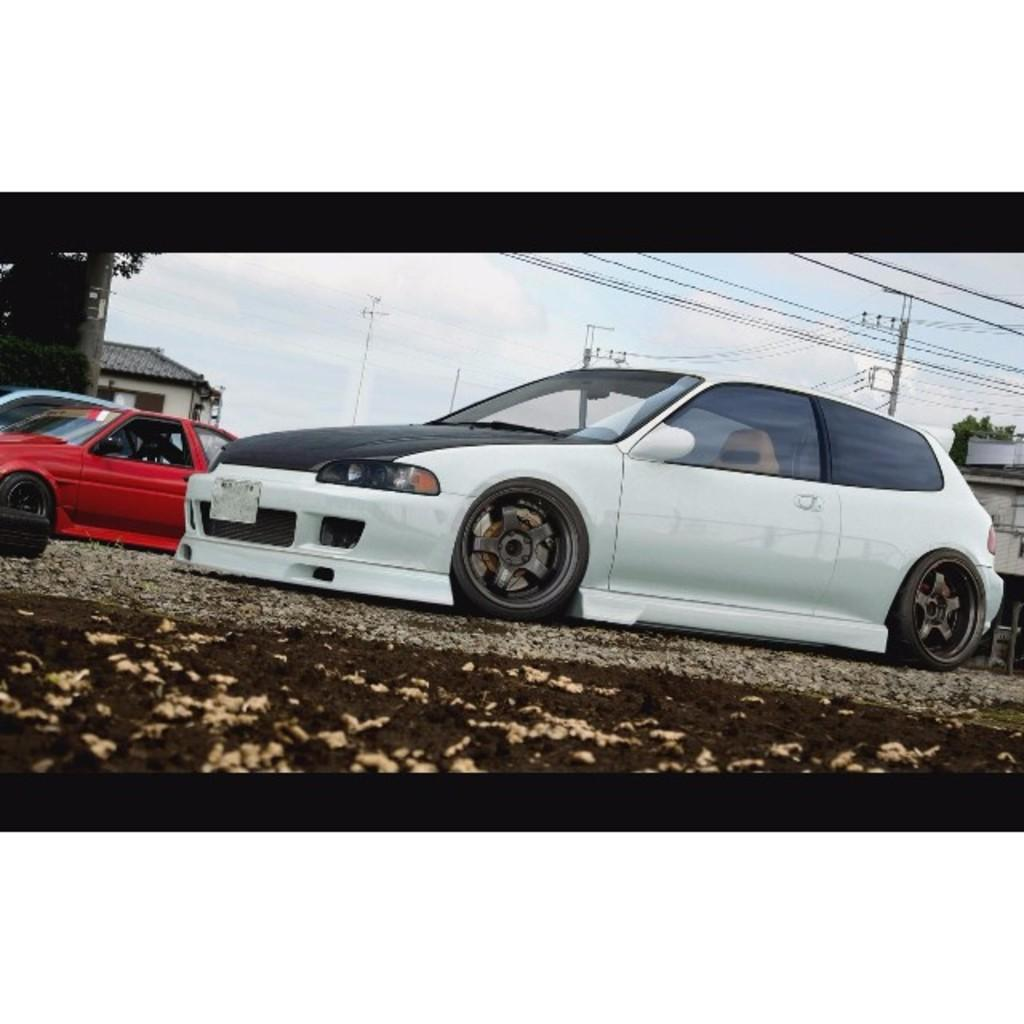What are the main subjects in the center of the image? There are two cars in the center of the image. What can be seen in the background of the image? There are houses and poles with wires in the background of the image. What type of vegetation is at the bottom of the image? There is grass at the bottom of the image. What effect does the temper of the cars have on the grass in the image? There is no indication of the cars' temper in the image, and the grass is not affected by any temper. 